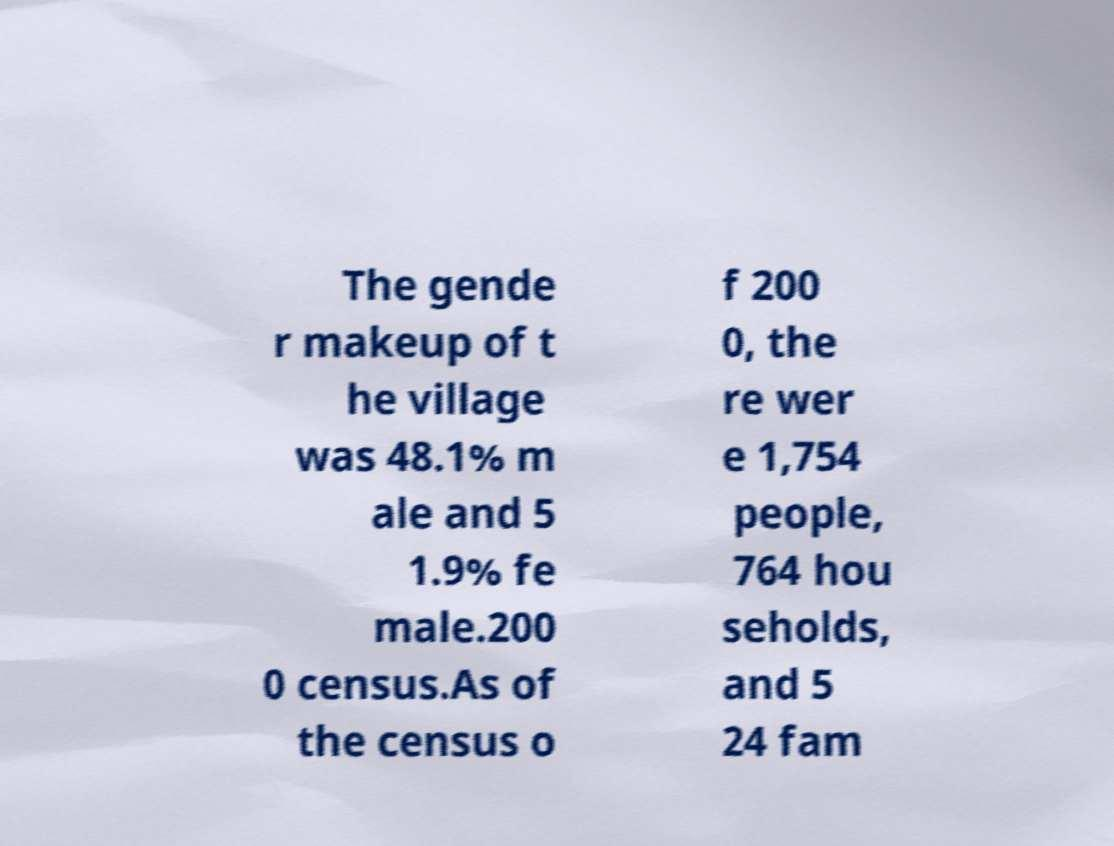There's text embedded in this image that I need extracted. Can you transcribe it verbatim? The gende r makeup of t he village was 48.1% m ale and 5 1.9% fe male.200 0 census.As of the census o f 200 0, the re wer e 1,754 people, 764 hou seholds, and 5 24 fam 